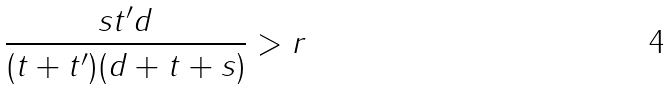Convert formula to latex. <formula><loc_0><loc_0><loc_500><loc_500>\frac { s t ^ { \prime } d } { ( t + t ^ { \prime } ) ( d + t + s ) } > r</formula> 